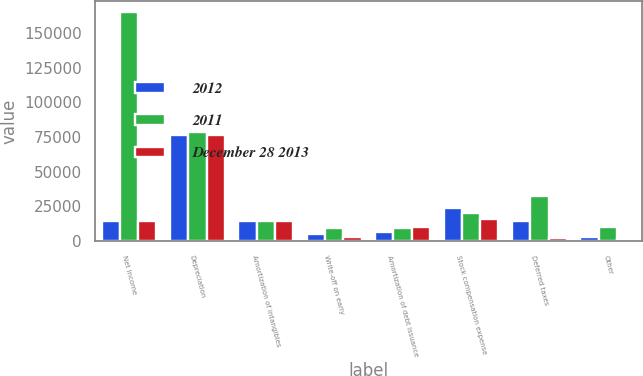Convert chart. <chart><loc_0><loc_0><loc_500><loc_500><stacked_bar_chart><ecel><fcel>Net income<fcel>Depreciation<fcel>Amortization of intangibles<fcel>Write-off on early<fcel>Amortization of debt issuance<fcel>Stock compensation expense<fcel>Deferred taxes<fcel>Other<nl><fcel>2012<fcel>14401.5<fcel>76125<fcel>14765<fcel>4865<fcel>6921<fcel>24178<fcel>14616<fcel>3027<nl><fcel>2011<fcel>164681<fcel>78784<fcel>14252<fcel>9559<fcel>9168<fcel>20496<fcel>32583<fcel>9813<nl><fcel>December 28 2013<fcel>14401.5<fcel>76174<fcel>14551<fcel>3297<fcel>10367<fcel>16173<fcel>1948<fcel>1661<nl></chart> 